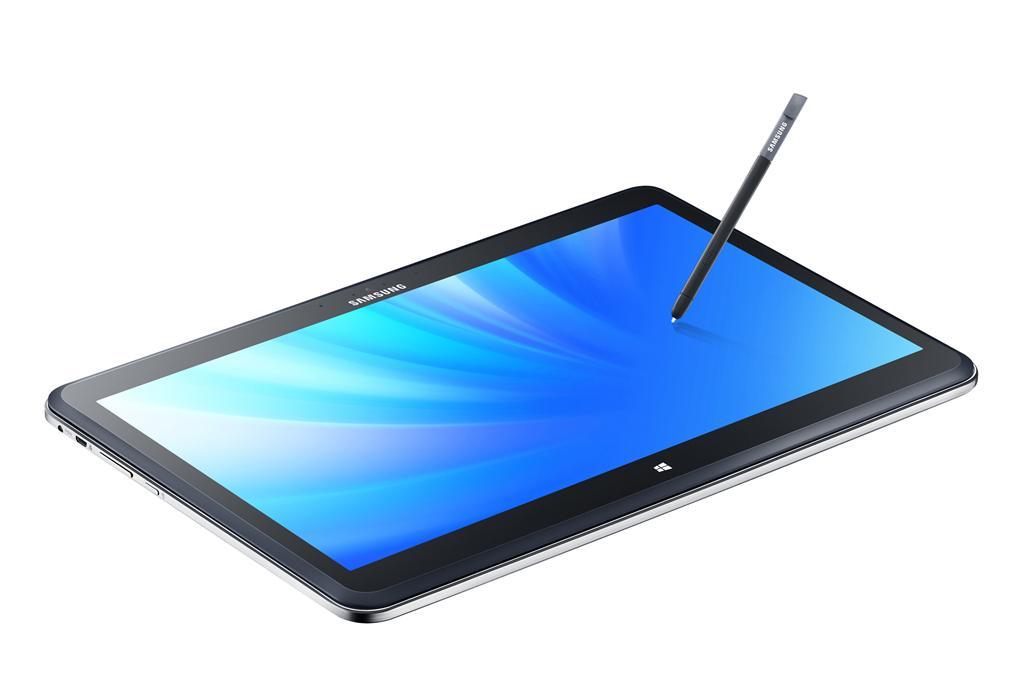Can you describe this image briefly? In this picture I can see there is a smartphone and it has few buttons and there is a pen and there is a white backdrop. 